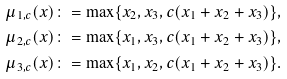<formula> <loc_0><loc_0><loc_500><loc_500>\mu _ { 1 , c } ( x ) \colon = \max \{ x _ { 2 } , x _ { 3 } , c ( x _ { 1 } + x _ { 2 } + x _ { 3 } ) \} , \\ \mu _ { 2 , c } ( x ) \colon = \max \{ x _ { 1 } , x _ { 3 } , c ( x _ { 1 } + x _ { 2 } + x _ { 3 } ) \} , \\ \mu _ { 3 , c } ( x ) \colon = \max \{ x _ { 1 } , x _ { 2 } , c ( x _ { 1 } + x _ { 2 } + x _ { 3 } ) \} .</formula> 